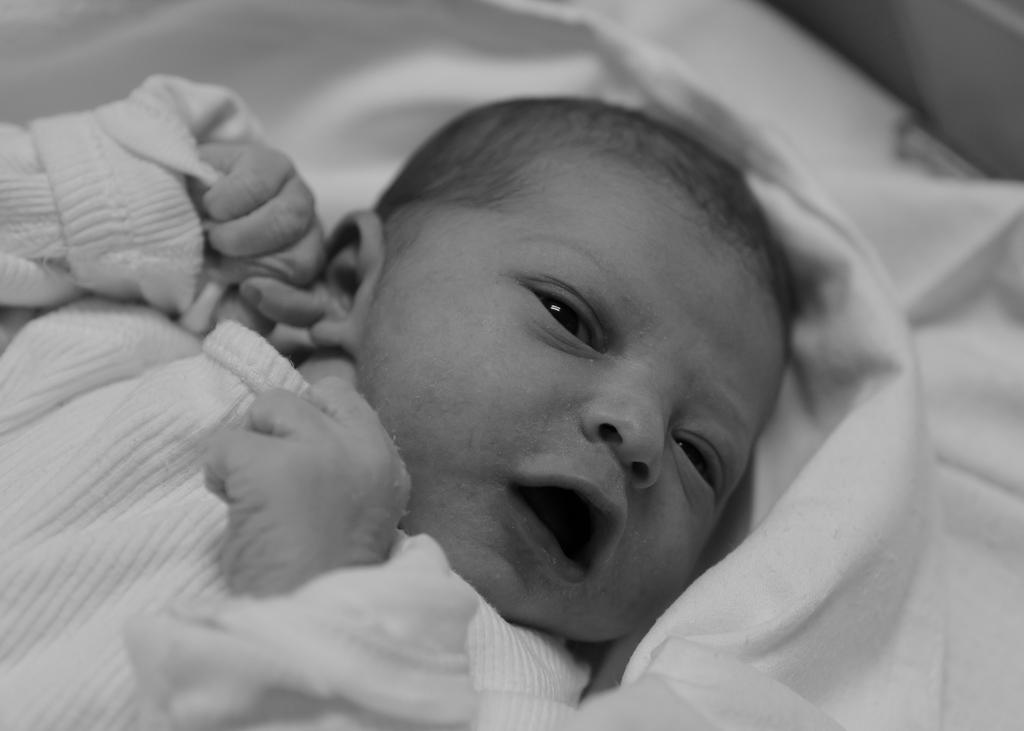What is the main subject of the image? The main subject of the image is a picture of a baby. What is the baby wearing in the image? The baby is wearing clothes in the image. What other object can be seen in the image besides the baby? There is a white cloth in the image. How many girls are present in the image? There is no mention of girls in the image, as the main subject is a picture of a baby. What type of sponge is being used for the baby's education in the image? There is no sponge or reference to education present in the image. 